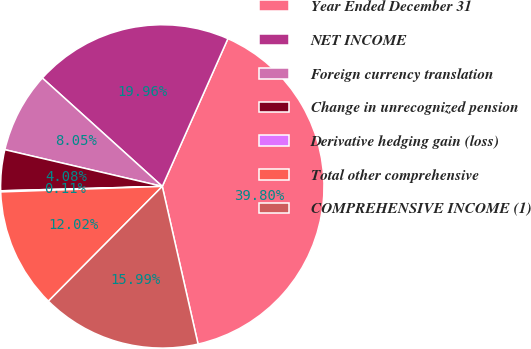Convert chart. <chart><loc_0><loc_0><loc_500><loc_500><pie_chart><fcel>Year Ended December 31<fcel>NET INCOME<fcel>Foreign currency translation<fcel>Change in unrecognized pension<fcel>Derivative hedging gain (loss)<fcel>Total other comprehensive<fcel>COMPREHENSIVE INCOME (1)<nl><fcel>39.8%<fcel>19.96%<fcel>8.05%<fcel>4.08%<fcel>0.11%<fcel>12.02%<fcel>15.99%<nl></chart> 